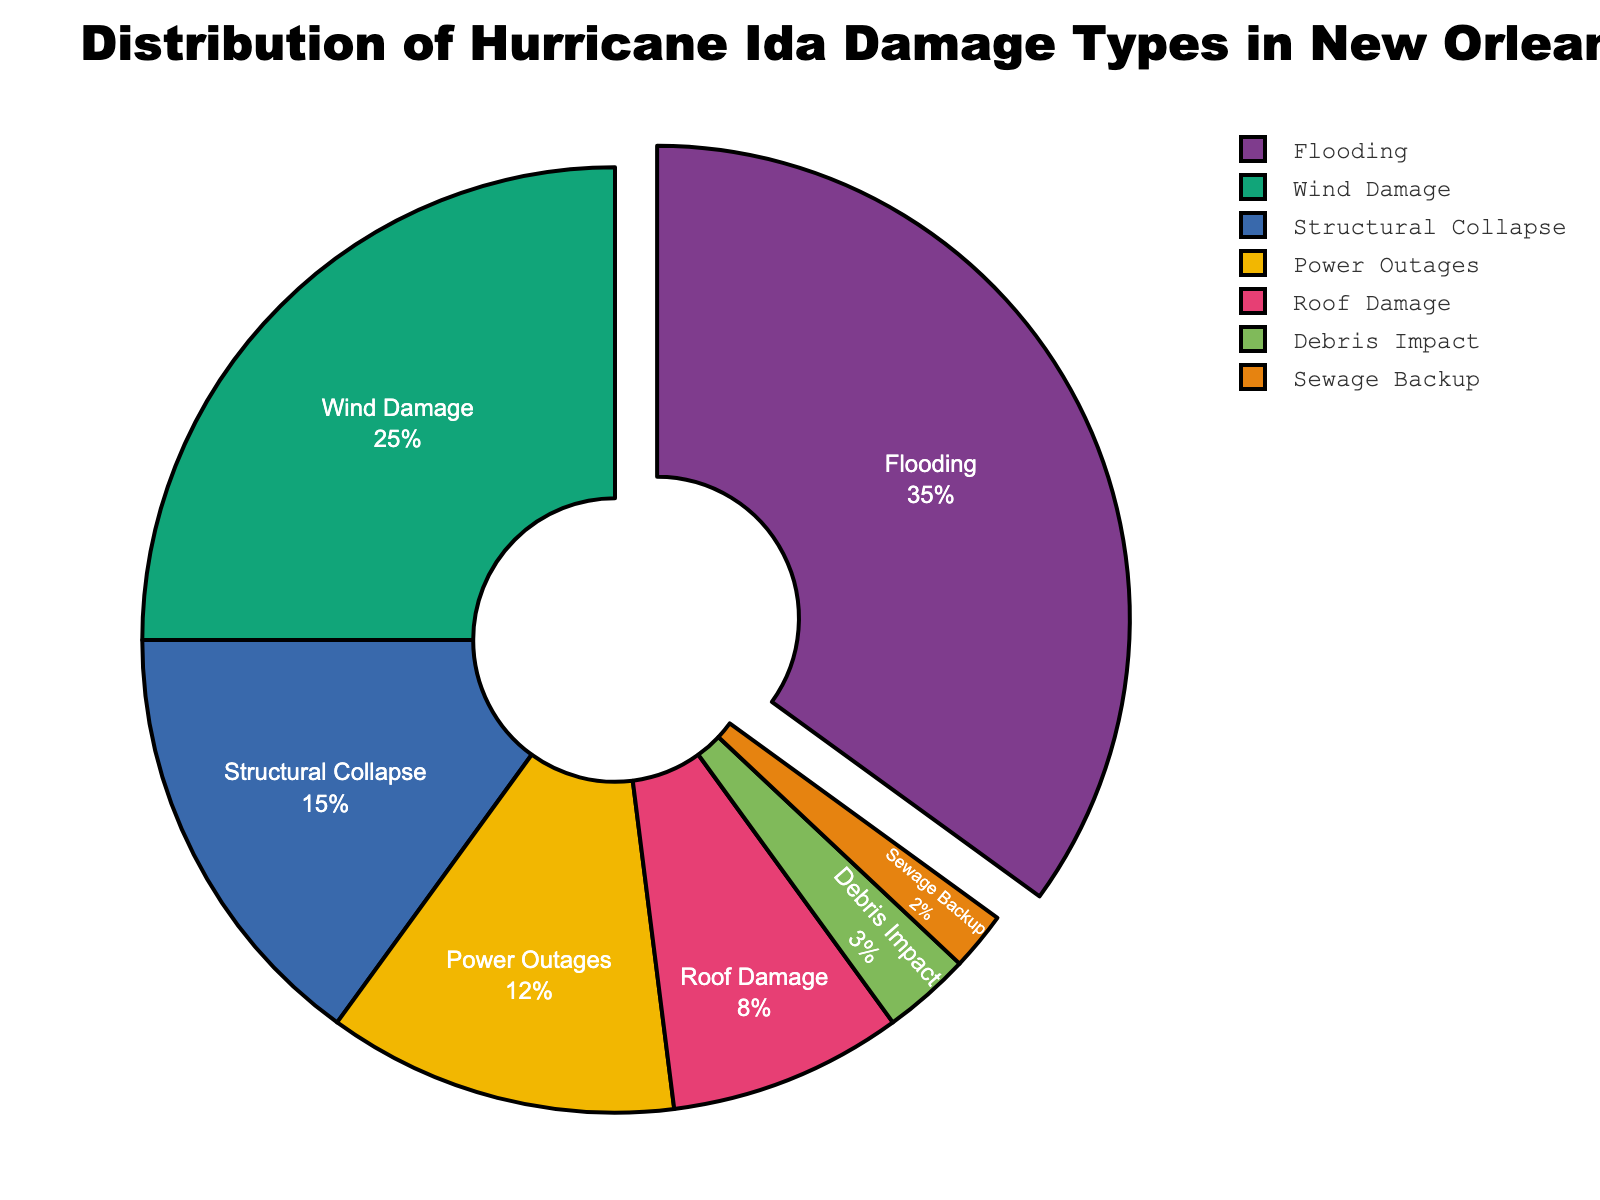what is the most common type of damage caused by Hurricane Ida? The most common type of damage can be identified by the largest segment in the pie chart. The largest segment represents Flooding at 35%.
Answer: Flooding What is the total percentage of wind damage and roof damage combined? Add the percentages for Wind Damage and Roof Damage. According to the chart, Wind Damage is 25% and Roof Damage is 8%. So, 25% + 8% = 33%.
Answer: 33% which type of damage occurred more frequently: structural collapse or sewage backup? Compare the sizes of the segments representing Structural Collapse and Sewage Backup. Structural Collapse is 15%, while Sewage Backup is 2%. Therefore, Structural Collapse occurred more frequently.
Answer: Structural Collapse How much larger is the flooding percentage compared to debris impact? To find the difference between the percentages, subtract the percentage for Debris Impact from the percentage for Flooding. Flooding is 35% and Debris Impact is 3%. So, 35% - 3% = 32%.
Answer: 32% Which type of damage accounts for the smallest percentage? Identify the smallest segment in the pie chart. The smallest segment represents Sewage Backup at 2%.
Answer: Sewage Backup What is the combined percentage of damage that includes power outages, roof damage, and debris impact? Sum the percentages for Power Outages, Roof Damage, and Debris Impact. Power Outages is 12%, Roof Damage is 8%, and Debris Impact is 3%. So, 12% + 8% + 3% = 23%.
Answer: 23% Which color represents the type of damage that is 25% of the total? Identify the segment that represents 25% of the total and describe its color. In this chart, the 25% segment corresponds to Wind Damage. The specific color may vary, but let's assume it is shown in the second colors category.
Answer: [Color corresponding to Wind Damage] What percentage of the damages are due to non-structural causes (excluding structural collapse)? Exclude the percentage of Structural Collapse and sum the remaining percentages. Structural Collapse is 15%, so sum Flooding (35%), Wind Damage (25%), Power Outages (12%), Roof Damage (8%), Debris Impact (3%), and Sewage Backup (2%). Therefore, 35% + 25% + 12% + 8% + 3% + 2% = 85%.
Answer: 85% How does the percentage of power outages compare to the percentage of roof damage? Compare the sizes of the segments representing Power Outages and Roof Damage. Power Outages is 12%, and Roof Damage is 8%. So, Power Outages is larger.
Answer: Power Outages What is the difference in percentage between the second most and the third most common types of damage? Identify the second and third most common damage types by looking at the segment sizes. Wind Damage is the second most common at 25%, and Structural Collapse is the third most common at 15%. The difference is 25% - 15% = 10%.
Answer: 10% 